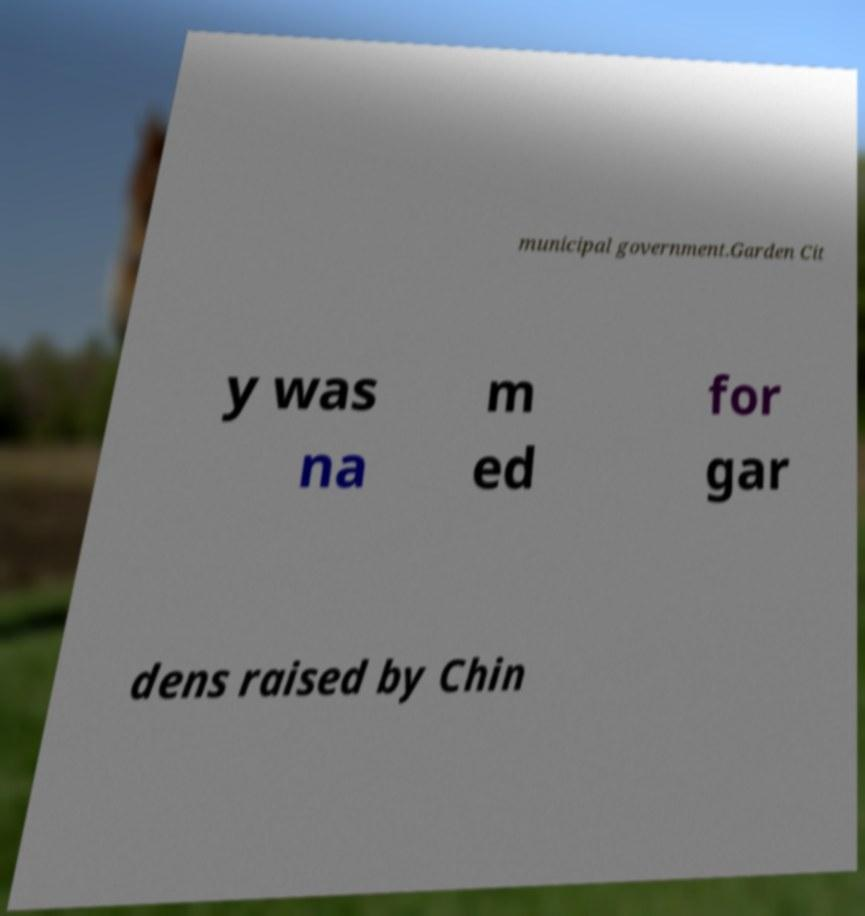Could you extract and type out the text from this image? municipal government.Garden Cit y was na m ed for gar dens raised by Chin 